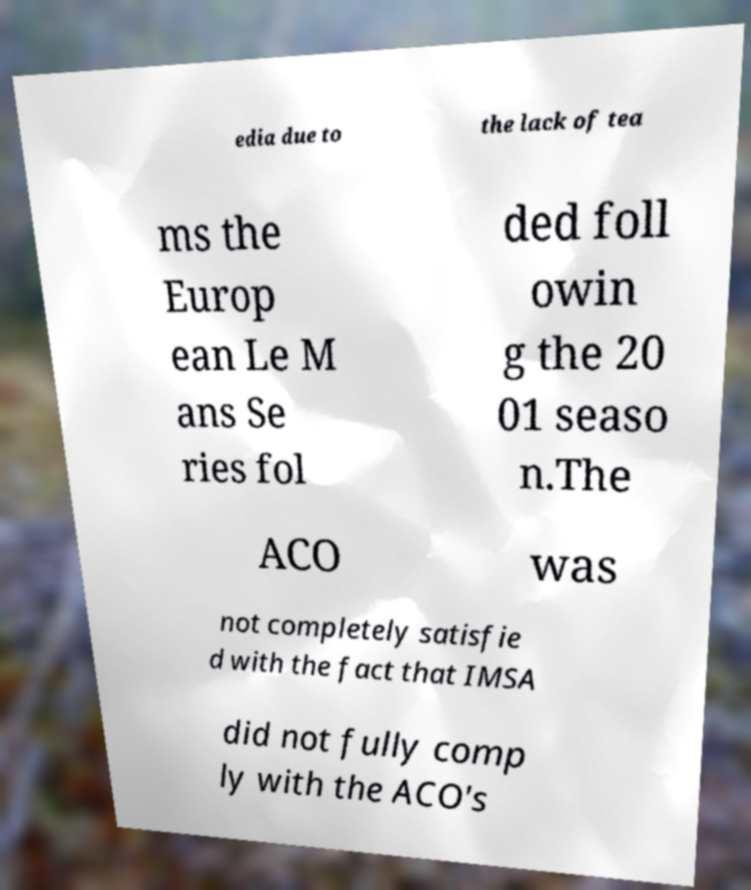What messages or text are displayed in this image? I need them in a readable, typed format. edia due to the lack of tea ms the Europ ean Le M ans Se ries fol ded foll owin g the 20 01 seaso n.The ACO was not completely satisfie d with the fact that IMSA did not fully comp ly with the ACO's 